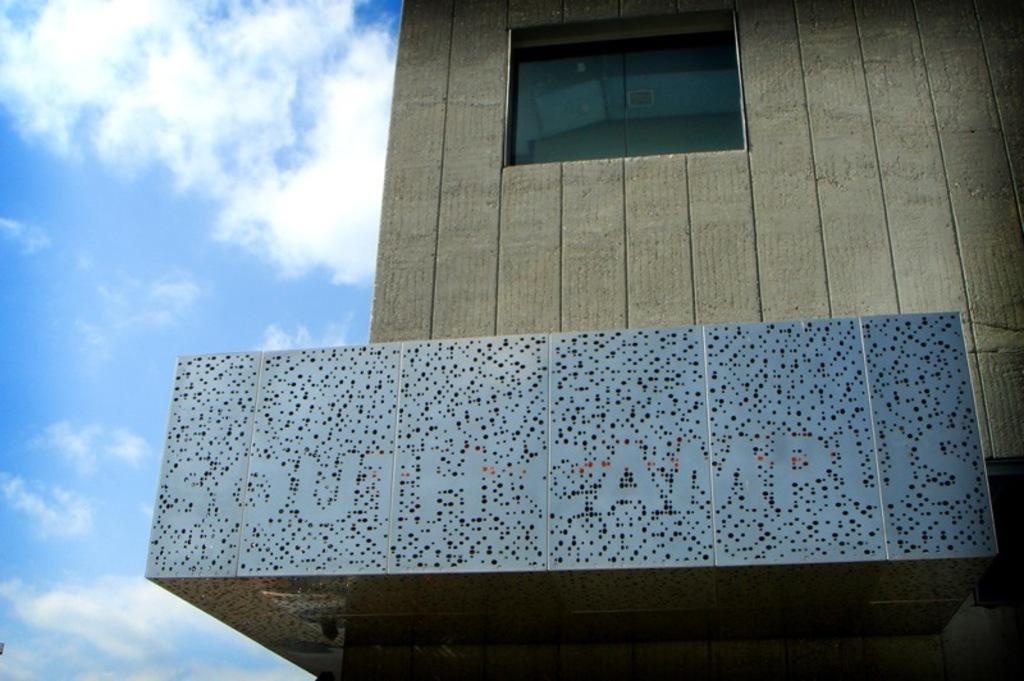What type of structure is present in the image? There is a building in the image. Is there any text or writing visible on the building? Yes, there is a name written on the building's wall. What type of note can be seen falling from the building in the image? There is no note or any object falling from the building in the image. 